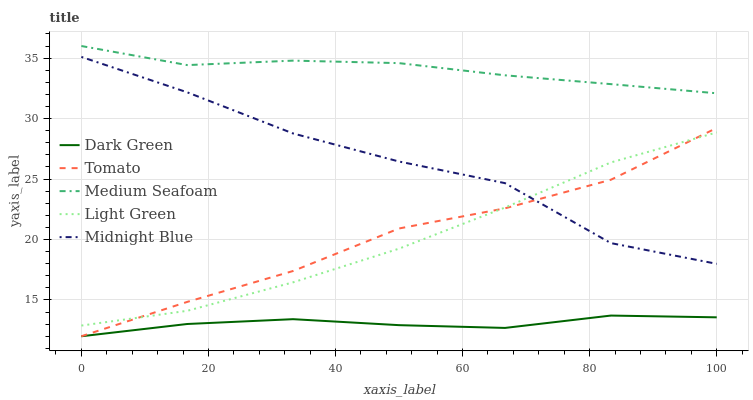Does Dark Green have the minimum area under the curve?
Answer yes or no. Yes. Does Midnight Blue have the minimum area under the curve?
Answer yes or no. No. Does Midnight Blue have the maximum area under the curve?
Answer yes or no. No. Is Midnight Blue the roughest?
Answer yes or no. Yes. Is Midnight Blue the smoothest?
Answer yes or no. No. Is Medium Seafoam the roughest?
Answer yes or no. No. Does Midnight Blue have the lowest value?
Answer yes or no. No. Does Midnight Blue have the highest value?
Answer yes or no. No. Is Light Green less than Medium Seafoam?
Answer yes or no. Yes. Is Medium Seafoam greater than Dark Green?
Answer yes or no. Yes. Does Light Green intersect Medium Seafoam?
Answer yes or no. No. 